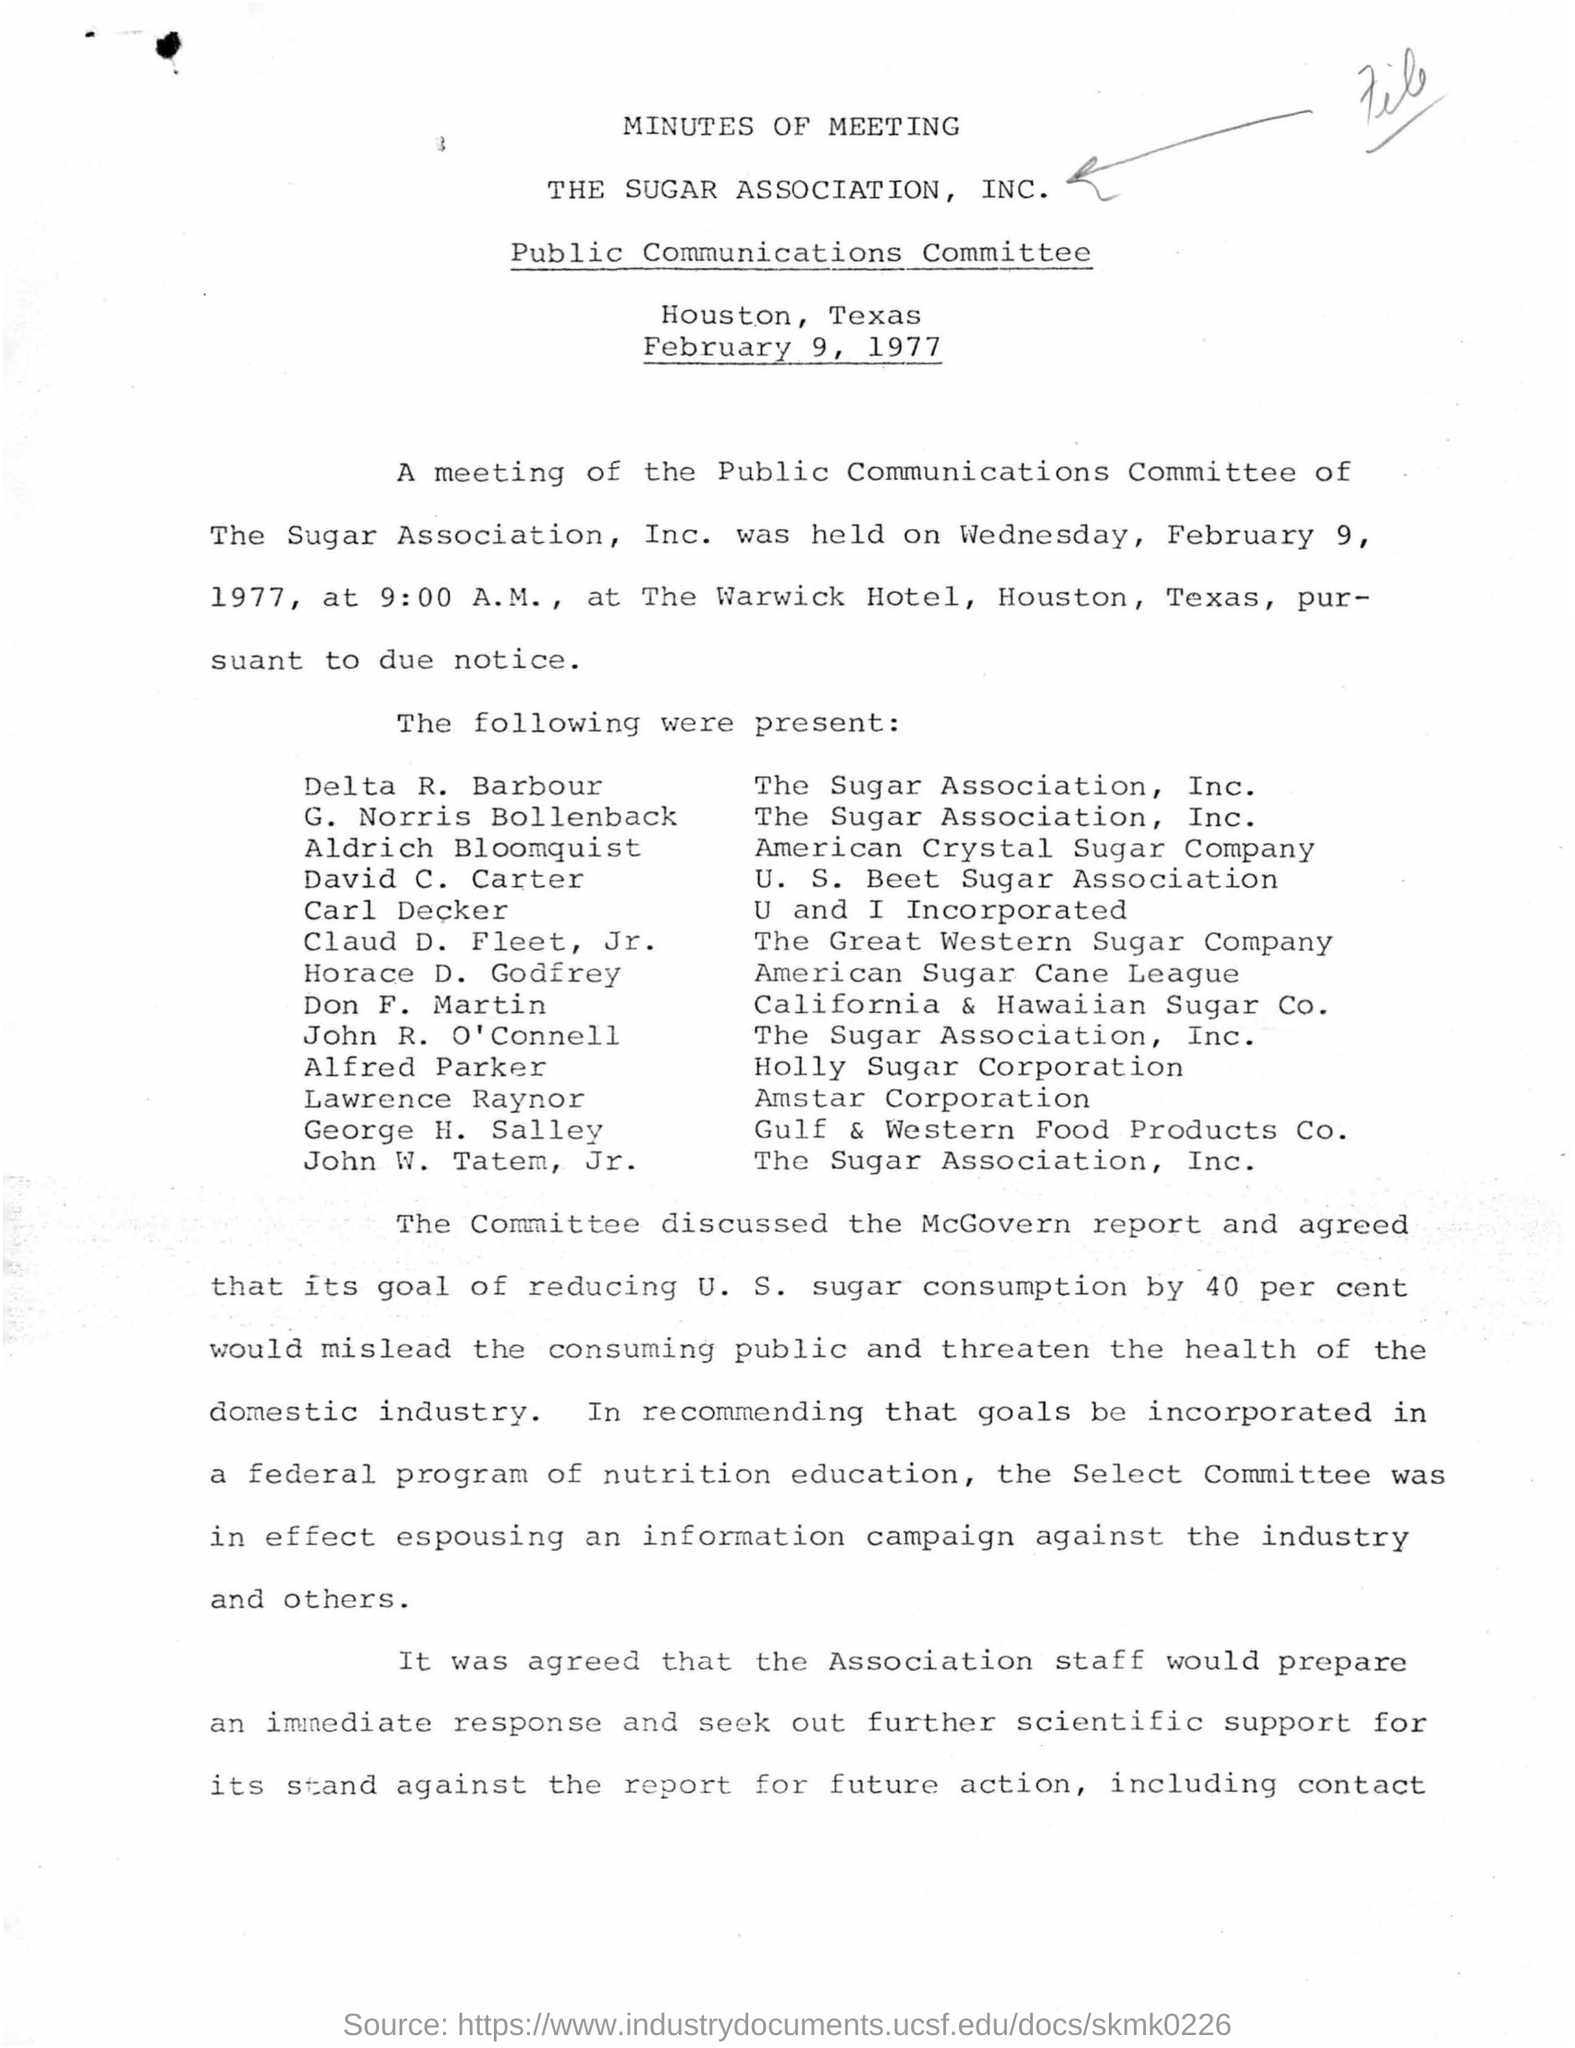What is the name of the association mentioned ?
Keep it short and to the point. The sugar association, inc. What is the name of the committee mentioned ?
Offer a very short reply. Public communications committee. What is the date mentioned in the given page ?
Offer a very short reply. FEBRUARY 9, 1977. At what time the meeting was scheduled ?
Give a very brief answer. 9:00 AM. What is the name of the hotel in which the meeting was scheduled ?
Offer a very short reply. The warwick hotel. 